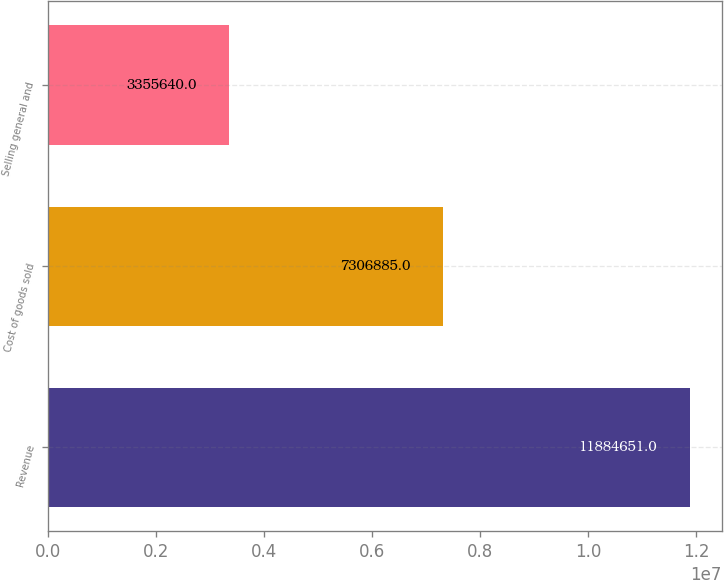<chart> <loc_0><loc_0><loc_500><loc_500><bar_chart><fcel>Revenue<fcel>Cost of goods sold<fcel>Selling general and<nl><fcel>1.18847e+07<fcel>7.30688e+06<fcel>3.35564e+06<nl></chart> 